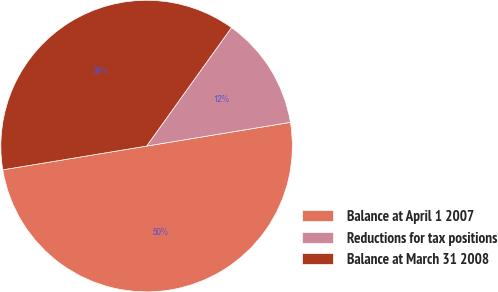Convert chart. <chart><loc_0><loc_0><loc_500><loc_500><pie_chart><fcel>Balance at April 1 2007<fcel>Reductions for tax positions<fcel>Balance at March 31 2008<nl><fcel>50.0%<fcel>12.5%<fcel>37.5%<nl></chart> 